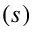<formula> <loc_0><loc_0><loc_500><loc_500>( s )</formula> 